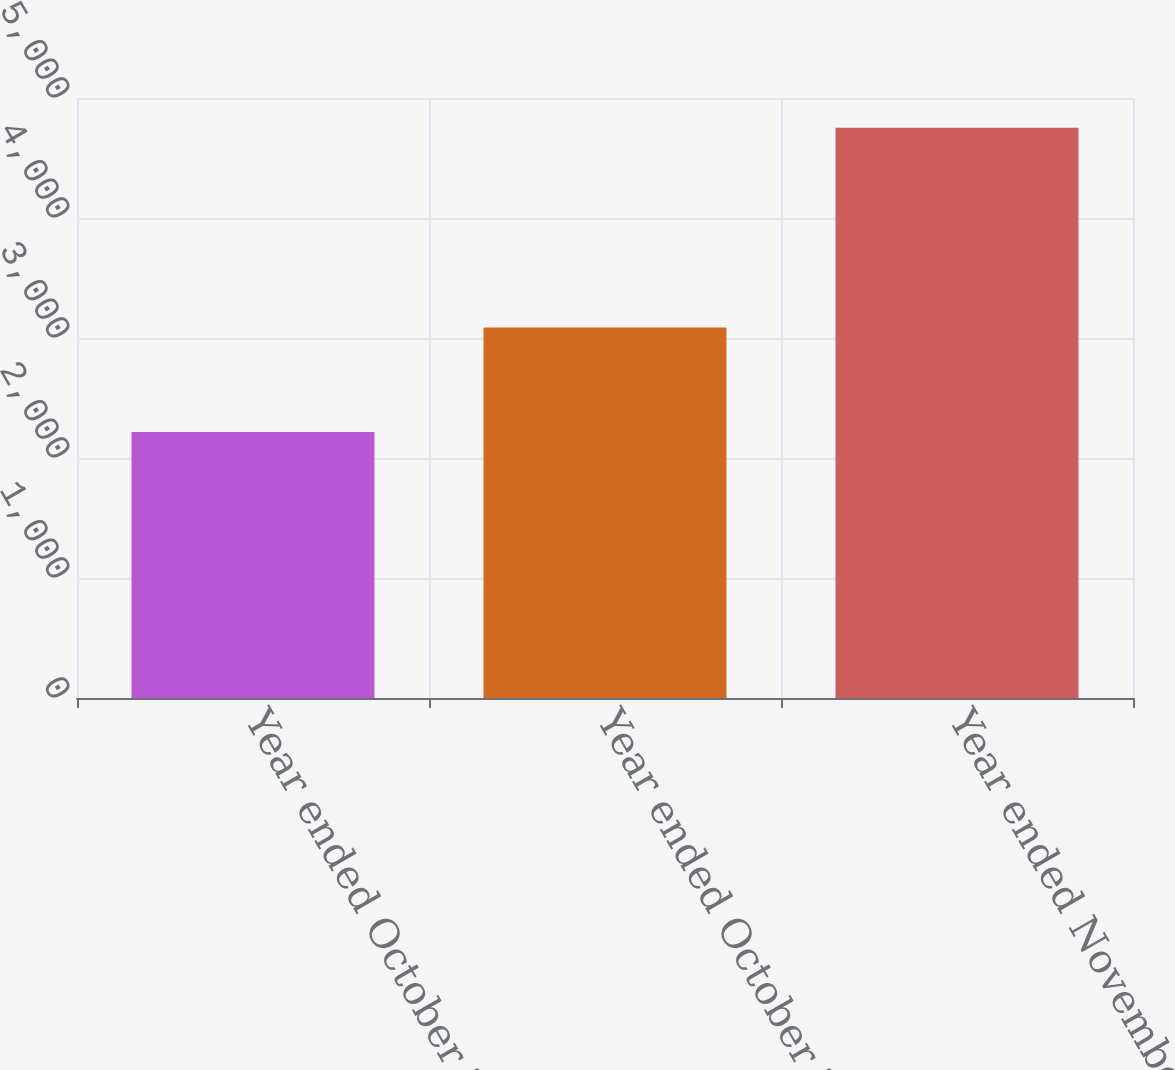Convert chart to OTSL. <chart><loc_0><loc_0><loc_500><loc_500><bar_chart><fcel>Year ended October 29 2005<fcel>Year ended October 28 2006<fcel>Year ended November 3 2007<nl><fcel>2216<fcel>3087<fcel>4753<nl></chart> 